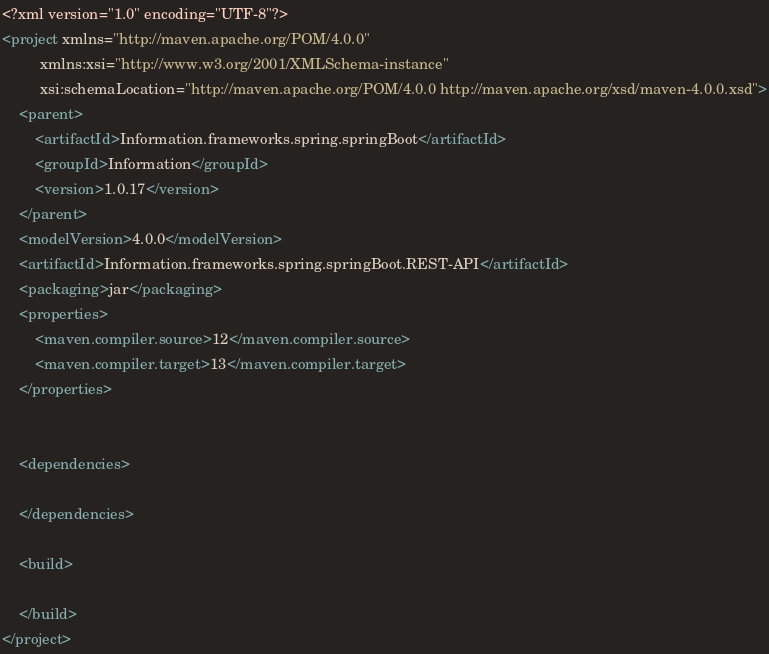<code> <loc_0><loc_0><loc_500><loc_500><_XML_><?xml version="1.0" encoding="UTF-8"?>
<project xmlns="http://maven.apache.org/POM/4.0.0"
         xmlns:xsi="http://www.w3.org/2001/XMLSchema-instance"
         xsi:schemaLocation="http://maven.apache.org/POM/4.0.0 http://maven.apache.org/xsd/maven-4.0.0.xsd">
    <parent>
        <artifactId>Information.frameworks.spring.springBoot</artifactId>
        <groupId>Information</groupId>
        <version>1.0.17</version>
    </parent>
    <modelVersion>4.0.0</modelVersion>
    <artifactId>Information.frameworks.spring.springBoot.REST-API</artifactId>
    <packaging>jar</packaging>
    <properties>
        <maven.compiler.source>12</maven.compiler.source>
        <maven.compiler.target>13</maven.compiler.target>
    </properties>


    <dependencies>

    </dependencies>

    <build>

    </build>
</project></code> 